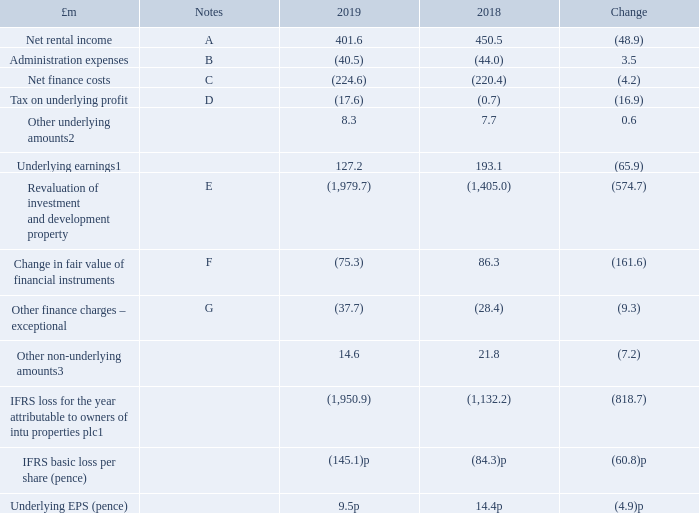Financial review
2019 was a challenging year for the retail property sector with the ongoing structural changes and low consumer confidence impacting some weaker retailers and leading to a higher level of CVAs and administrations. This impacted our revenue, net rental income and property valuations, with like-for-like net rental income down 9.1 per cent and the property revaluation deficit was £1,979.7 million.
Fixing the balance sheet is our top strategic priority and although the notes accompanying these financial statements indicate a material uncertainty in relation to intu’s ability to continue as a going concern we have options including alternative capital structures and further disposals to put us on a stronger financial footing.
1 A reconciliation from the IFRS consolidated income statement to the underlying earnings amounts presented above is provided in presentation of information on page 161.
2 Other underlying amounts includes net other income, share of underlying profit in associates and any underlying amounts attributable to non-controlling interests.
3 Other non-underlying amounts includes losses on disposal of subsidiaries, gains on sale of investment and development property, write-down on recognition of joint ventures and other assets classified as held for sale, impairment of goodwill, impairment of investment in associates, impairment of loan to associate, exceptional administration expenses, exceptional tax, and any non-underlying amounts attributable to non-controlling interests.
The IFRS loss for the year attributable to owners of intu properties plc increased by £818.7 million to £1,950.9 million, with the IFRS basic loss per share increasing by 60.8 pence. Underlying earnings decreased by £65.9 million to £127.2 million, with a corresponding reduction in underlying EPS of 4.9 pence. The key drivers of these variances are discussed below.
What is the net rental income in 2019?
Answer scale should be: million. 401.6. What is the administration expense in 2019?
Answer scale should be: million. 40.5. What is the net finance cost in 2019?
Answer scale should be: million. 224.6. What is the percentage change in the net rental income from 2018 to 2019?
Answer scale should be: percent. 48.9/450.5
Answer: 10.85. What is the percentage change in the administration expenses from 2018 to 2019?
Answer scale should be: percent. 3.5/44.0
Answer: 7.95. What is the percentage change in the net finance costs from 2018 to 2019?
Answer scale should be: percent. (4.2)/220.4
Answer: -1.91. 